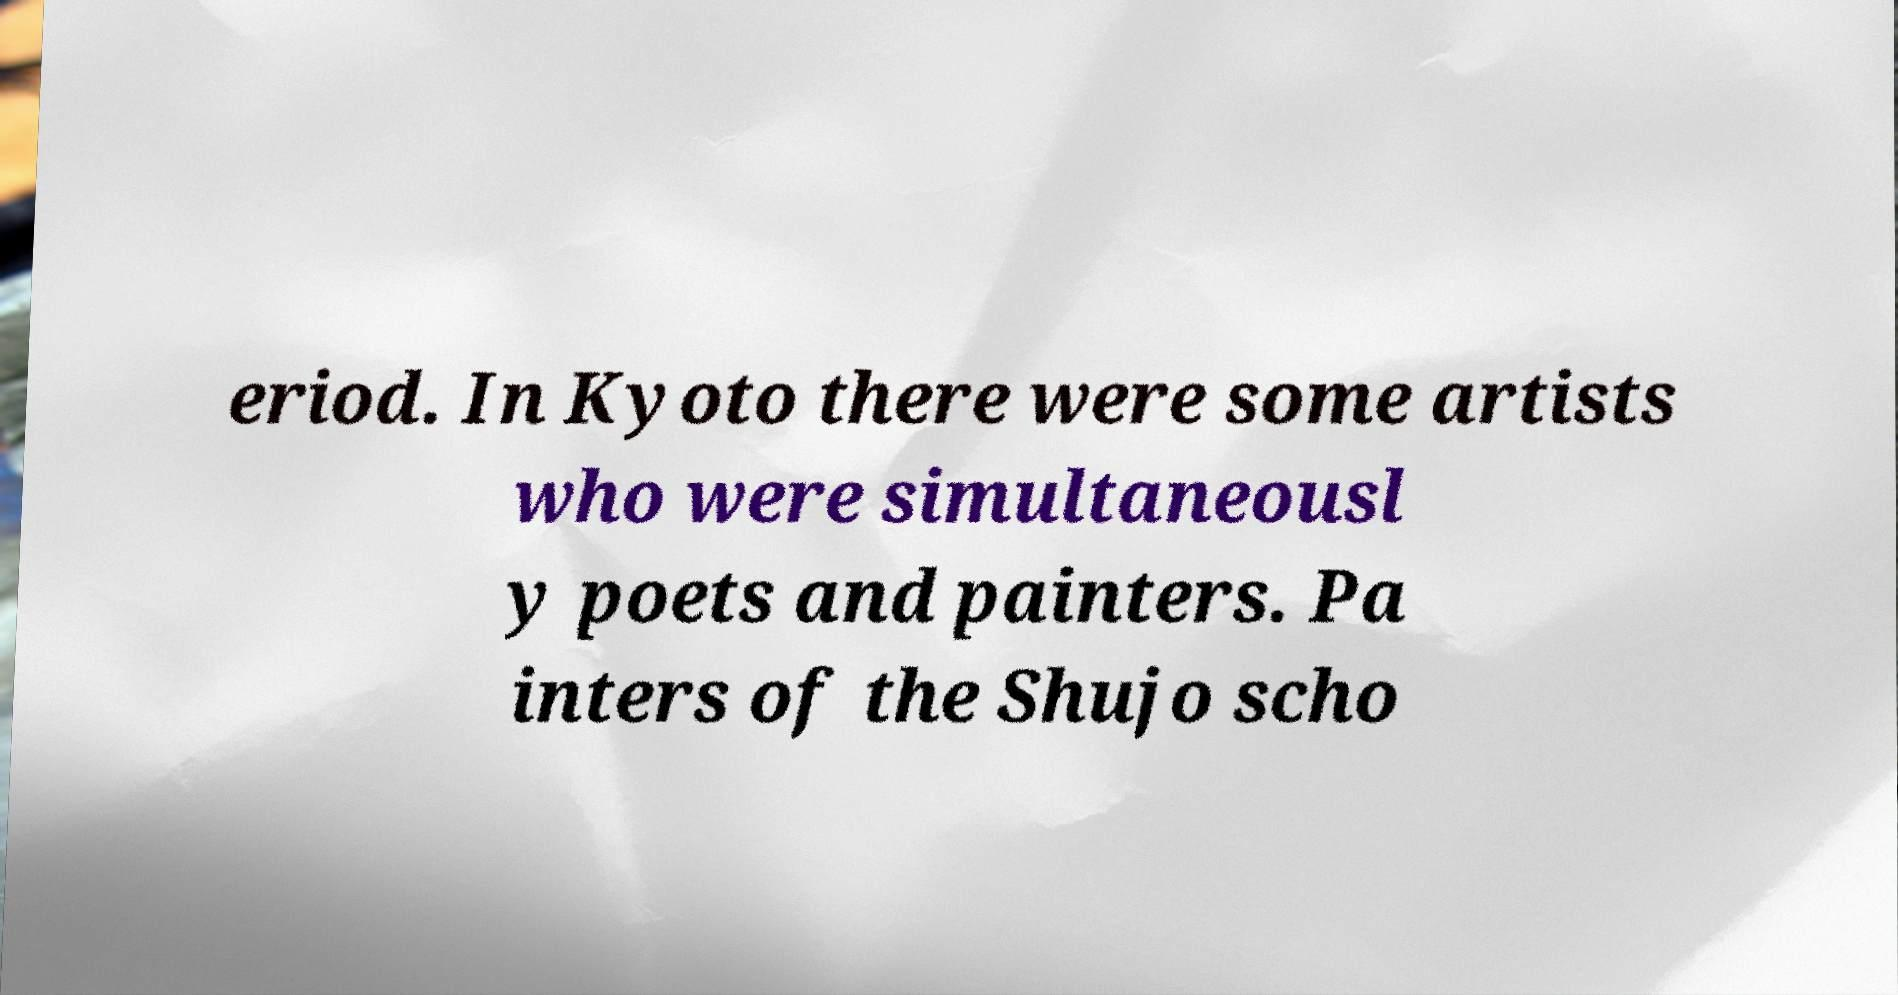Please read and relay the text visible in this image. What does it say? eriod. In Kyoto there were some artists who were simultaneousl y poets and painters. Pa inters of the Shujo scho 